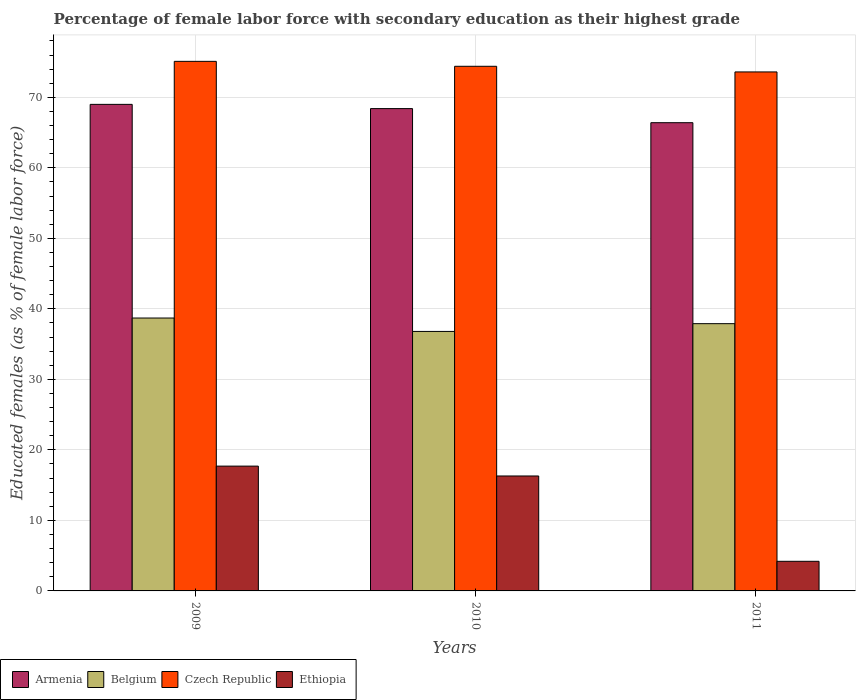Are the number of bars per tick equal to the number of legend labels?
Offer a terse response. Yes. How many bars are there on the 2nd tick from the left?
Offer a terse response. 4. What is the percentage of female labor force with secondary education in Ethiopia in 2011?
Offer a very short reply. 4.2. Across all years, what is the maximum percentage of female labor force with secondary education in Belgium?
Give a very brief answer. 38.7. Across all years, what is the minimum percentage of female labor force with secondary education in Belgium?
Ensure brevity in your answer.  36.8. In which year was the percentage of female labor force with secondary education in Czech Republic maximum?
Give a very brief answer. 2009. What is the total percentage of female labor force with secondary education in Belgium in the graph?
Your answer should be very brief. 113.4. What is the difference between the percentage of female labor force with secondary education in Armenia in 2009 and that in 2010?
Make the answer very short. 0.6. What is the difference between the percentage of female labor force with secondary education in Belgium in 2011 and the percentage of female labor force with secondary education in Czech Republic in 2010?
Keep it short and to the point. -36.5. What is the average percentage of female labor force with secondary education in Armenia per year?
Give a very brief answer. 67.93. In the year 2009, what is the difference between the percentage of female labor force with secondary education in Czech Republic and percentage of female labor force with secondary education in Ethiopia?
Your response must be concise. 57.4. What is the ratio of the percentage of female labor force with secondary education in Ethiopia in 2009 to that in 2011?
Offer a terse response. 4.21. Is the percentage of female labor force with secondary education in Czech Republic in 2010 less than that in 2011?
Offer a terse response. No. What is the difference between the highest and the second highest percentage of female labor force with secondary education in Armenia?
Your answer should be compact. 0.6. What is the difference between the highest and the lowest percentage of female labor force with secondary education in Belgium?
Offer a very short reply. 1.9. In how many years, is the percentage of female labor force with secondary education in Ethiopia greater than the average percentage of female labor force with secondary education in Ethiopia taken over all years?
Make the answer very short. 2. Is the sum of the percentage of female labor force with secondary education in Czech Republic in 2009 and 2011 greater than the maximum percentage of female labor force with secondary education in Belgium across all years?
Give a very brief answer. Yes. What does the 4th bar from the left in 2011 represents?
Your answer should be compact. Ethiopia. What does the 4th bar from the right in 2009 represents?
Offer a very short reply. Armenia. How many bars are there?
Provide a succinct answer. 12. How many years are there in the graph?
Make the answer very short. 3. Does the graph contain any zero values?
Your response must be concise. No. Does the graph contain grids?
Provide a succinct answer. Yes. Where does the legend appear in the graph?
Your answer should be very brief. Bottom left. How many legend labels are there?
Offer a very short reply. 4. What is the title of the graph?
Your answer should be very brief. Percentage of female labor force with secondary education as their highest grade. What is the label or title of the Y-axis?
Provide a short and direct response. Educated females (as % of female labor force). What is the Educated females (as % of female labor force) in Belgium in 2009?
Offer a very short reply. 38.7. What is the Educated females (as % of female labor force) of Czech Republic in 2009?
Offer a terse response. 75.1. What is the Educated females (as % of female labor force) in Ethiopia in 2009?
Your response must be concise. 17.7. What is the Educated females (as % of female labor force) of Armenia in 2010?
Provide a succinct answer. 68.4. What is the Educated females (as % of female labor force) of Belgium in 2010?
Offer a terse response. 36.8. What is the Educated females (as % of female labor force) in Czech Republic in 2010?
Your answer should be very brief. 74.4. What is the Educated females (as % of female labor force) in Ethiopia in 2010?
Ensure brevity in your answer.  16.3. What is the Educated females (as % of female labor force) in Armenia in 2011?
Provide a succinct answer. 66.4. What is the Educated females (as % of female labor force) in Belgium in 2011?
Your answer should be compact. 37.9. What is the Educated females (as % of female labor force) of Czech Republic in 2011?
Ensure brevity in your answer.  73.6. What is the Educated females (as % of female labor force) of Ethiopia in 2011?
Ensure brevity in your answer.  4.2. Across all years, what is the maximum Educated females (as % of female labor force) of Belgium?
Make the answer very short. 38.7. Across all years, what is the maximum Educated females (as % of female labor force) in Czech Republic?
Make the answer very short. 75.1. Across all years, what is the maximum Educated females (as % of female labor force) in Ethiopia?
Your response must be concise. 17.7. Across all years, what is the minimum Educated females (as % of female labor force) in Armenia?
Your answer should be compact. 66.4. Across all years, what is the minimum Educated females (as % of female labor force) of Belgium?
Provide a short and direct response. 36.8. Across all years, what is the minimum Educated females (as % of female labor force) in Czech Republic?
Offer a very short reply. 73.6. Across all years, what is the minimum Educated females (as % of female labor force) of Ethiopia?
Your response must be concise. 4.2. What is the total Educated females (as % of female labor force) in Armenia in the graph?
Give a very brief answer. 203.8. What is the total Educated females (as % of female labor force) of Belgium in the graph?
Your response must be concise. 113.4. What is the total Educated females (as % of female labor force) in Czech Republic in the graph?
Ensure brevity in your answer.  223.1. What is the total Educated females (as % of female labor force) in Ethiopia in the graph?
Provide a short and direct response. 38.2. What is the difference between the Educated females (as % of female labor force) in Armenia in 2009 and that in 2010?
Provide a succinct answer. 0.6. What is the difference between the Educated females (as % of female labor force) of Belgium in 2009 and that in 2010?
Provide a short and direct response. 1.9. What is the difference between the Educated females (as % of female labor force) of Armenia in 2009 and that in 2011?
Offer a terse response. 2.6. What is the difference between the Educated females (as % of female labor force) of Belgium in 2009 and that in 2011?
Your response must be concise. 0.8. What is the difference between the Educated females (as % of female labor force) in Czech Republic in 2009 and that in 2011?
Keep it short and to the point. 1.5. What is the difference between the Educated females (as % of female labor force) of Armenia in 2010 and that in 2011?
Offer a very short reply. 2. What is the difference between the Educated females (as % of female labor force) of Czech Republic in 2010 and that in 2011?
Your answer should be compact. 0.8. What is the difference between the Educated females (as % of female labor force) in Armenia in 2009 and the Educated females (as % of female labor force) in Belgium in 2010?
Provide a short and direct response. 32.2. What is the difference between the Educated females (as % of female labor force) of Armenia in 2009 and the Educated females (as % of female labor force) of Czech Republic in 2010?
Provide a short and direct response. -5.4. What is the difference between the Educated females (as % of female labor force) of Armenia in 2009 and the Educated females (as % of female labor force) of Ethiopia in 2010?
Ensure brevity in your answer.  52.7. What is the difference between the Educated females (as % of female labor force) of Belgium in 2009 and the Educated females (as % of female labor force) of Czech Republic in 2010?
Offer a terse response. -35.7. What is the difference between the Educated females (as % of female labor force) of Belgium in 2009 and the Educated females (as % of female labor force) of Ethiopia in 2010?
Provide a short and direct response. 22.4. What is the difference between the Educated females (as % of female labor force) in Czech Republic in 2009 and the Educated females (as % of female labor force) in Ethiopia in 2010?
Your answer should be compact. 58.8. What is the difference between the Educated females (as % of female labor force) of Armenia in 2009 and the Educated females (as % of female labor force) of Belgium in 2011?
Offer a terse response. 31.1. What is the difference between the Educated females (as % of female labor force) in Armenia in 2009 and the Educated females (as % of female labor force) in Ethiopia in 2011?
Your response must be concise. 64.8. What is the difference between the Educated females (as % of female labor force) of Belgium in 2009 and the Educated females (as % of female labor force) of Czech Republic in 2011?
Provide a short and direct response. -34.9. What is the difference between the Educated females (as % of female labor force) in Belgium in 2009 and the Educated females (as % of female labor force) in Ethiopia in 2011?
Ensure brevity in your answer.  34.5. What is the difference between the Educated females (as % of female labor force) in Czech Republic in 2009 and the Educated females (as % of female labor force) in Ethiopia in 2011?
Provide a succinct answer. 70.9. What is the difference between the Educated females (as % of female labor force) in Armenia in 2010 and the Educated females (as % of female labor force) in Belgium in 2011?
Your response must be concise. 30.5. What is the difference between the Educated females (as % of female labor force) in Armenia in 2010 and the Educated females (as % of female labor force) in Czech Republic in 2011?
Your answer should be very brief. -5.2. What is the difference between the Educated females (as % of female labor force) in Armenia in 2010 and the Educated females (as % of female labor force) in Ethiopia in 2011?
Give a very brief answer. 64.2. What is the difference between the Educated females (as % of female labor force) in Belgium in 2010 and the Educated females (as % of female labor force) in Czech Republic in 2011?
Offer a very short reply. -36.8. What is the difference between the Educated females (as % of female labor force) of Belgium in 2010 and the Educated females (as % of female labor force) of Ethiopia in 2011?
Offer a very short reply. 32.6. What is the difference between the Educated females (as % of female labor force) of Czech Republic in 2010 and the Educated females (as % of female labor force) of Ethiopia in 2011?
Provide a short and direct response. 70.2. What is the average Educated females (as % of female labor force) of Armenia per year?
Keep it short and to the point. 67.93. What is the average Educated females (as % of female labor force) in Belgium per year?
Your answer should be compact. 37.8. What is the average Educated females (as % of female labor force) of Czech Republic per year?
Your answer should be very brief. 74.37. What is the average Educated females (as % of female labor force) of Ethiopia per year?
Offer a very short reply. 12.73. In the year 2009, what is the difference between the Educated females (as % of female labor force) in Armenia and Educated females (as % of female labor force) in Belgium?
Ensure brevity in your answer.  30.3. In the year 2009, what is the difference between the Educated females (as % of female labor force) of Armenia and Educated females (as % of female labor force) of Ethiopia?
Provide a short and direct response. 51.3. In the year 2009, what is the difference between the Educated females (as % of female labor force) of Belgium and Educated females (as % of female labor force) of Czech Republic?
Give a very brief answer. -36.4. In the year 2009, what is the difference between the Educated females (as % of female labor force) in Czech Republic and Educated females (as % of female labor force) in Ethiopia?
Keep it short and to the point. 57.4. In the year 2010, what is the difference between the Educated females (as % of female labor force) in Armenia and Educated females (as % of female labor force) in Belgium?
Ensure brevity in your answer.  31.6. In the year 2010, what is the difference between the Educated females (as % of female labor force) of Armenia and Educated females (as % of female labor force) of Czech Republic?
Make the answer very short. -6. In the year 2010, what is the difference between the Educated females (as % of female labor force) of Armenia and Educated females (as % of female labor force) of Ethiopia?
Ensure brevity in your answer.  52.1. In the year 2010, what is the difference between the Educated females (as % of female labor force) of Belgium and Educated females (as % of female labor force) of Czech Republic?
Your answer should be compact. -37.6. In the year 2010, what is the difference between the Educated females (as % of female labor force) in Belgium and Educated females (as % of female labor force) in Ethiopia?
Give a very brief answer. 20.5. In the year 2010, what is the difference between the Educated females (as % of female labor force) of Czech Republic and Educated females (as % of female labor force) of Ethiopia?
Offer a terse response. 58.1. In the year 2011, what is the difference between the Educated females (as % of female labor force) in Armenia and Educated females (as % of female labor force) in Czech Republic?
Keep it short and to the point. -7.2. In the year 2011, what is the difference between the Educated females (as % of female labor force) of Armenia and Educated females (as % of female labor force) of Ethiopia?
Your answer should be compact. 62.2. In the year 2011, what is the difference between the Educated females (as % of female labor force) of Belgium and Educated females (as % of female labor force) of Czech Republic?
Provide a short and direct response. -35.7. In the year 2011, what is the difference between the Educated females (as % of female labor force) of Belgium and Educated females (as % of female labor force) of Ethiopia?
Offer a very short reply. 33.7. In the year 2011, what is the difference between the Educated females (as % of female labor force) of Czech Republic and Educated females (as % of female labor force) of Ethiopia?
Your response must be concise. 69.4. What is the ratio of the Educated females (as % of female labor force) in Armenia in 2009 to that in 2010?
Make the answer very short. 1.01. What is the ratio of the Educated females (as % of female labor force) of Belgium in 2009 to that in 2010?
Your answer should be very brief. 1.05. What is the ratio of the Educated females (as % of female labor force) in Czech Republic in 2009 to that in 2010?
Provide a succinct answer. 1.01. What is the ratio of the Educated females (as % of female labor force) of Ethiopia in 2009 to that in 2010?
Ensure brevity in your answer.  1.09. What is the ratio of the Educated females (as % of female labor force) of Armenia in 2009 to that in 2011?
Your response must be concise. 1.04. What is the ratio of the Educated females (as % of female labor force) in Belgium in 2009 to that in 2011?
Ensure brevity in your answer.  1.02. What is the ratio of the Educated females (as % of female labor force) of Czech Republic in 2009 to that in 2011?
Keep it short and to the point. 1.02. What is the ratio of the Educated females (as % of female labor force) in Ethiopia in 2009 to that in 2011?
Offer a terse response. 4.21. What is the ratio of the Educated females (as % of female labor force) in Armenia in 2010 to that in 2011?
Offer a terse response. 1.03. What is the ratio of the Educated females (as % of female labor force) of Czech Republic in 2010 to that in 2011?
Make the answer very short. 1.01. What is the ratio of the Educated females (as % of female labor force) of Ethiopia in 2010 to that in 2011?
Your answer should be compact. 3.88. What is the difference between the highest and the second highest Educated females (as % of female labor force) of Armenia?
Provide a short and direct response. 0.6. What is the difference between the highest and the second highest Educated females (as % of female labor force) in Belgium?
Give a very brief answer. 0.8. What is the difference between the highest and the second highest Educated females (as % of female labor force) in Czech Republic?
Give a very brief answer. 0.7. What is the difference between the highest and the second highest Educated females (as % of female labor force) in Ethiopia?
Your answer should be very brief. 1.4. What is the difference between the highest and the lowest Educated females (as % of female labor force) in Armenia?
Your answer should be very brief. 2.6. 